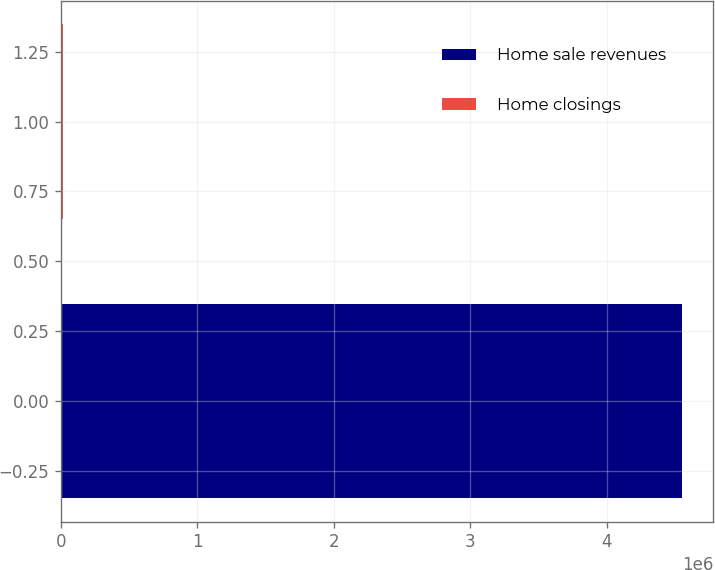Convert chart to OTSL. <chart><loc_0><loc_0><loc_500><loc_500><bar_chart><fcel>Home sale revenues<fcel>Home closings<nl><fcel>4.55241e+06<fcel>16505<nl></chart> 